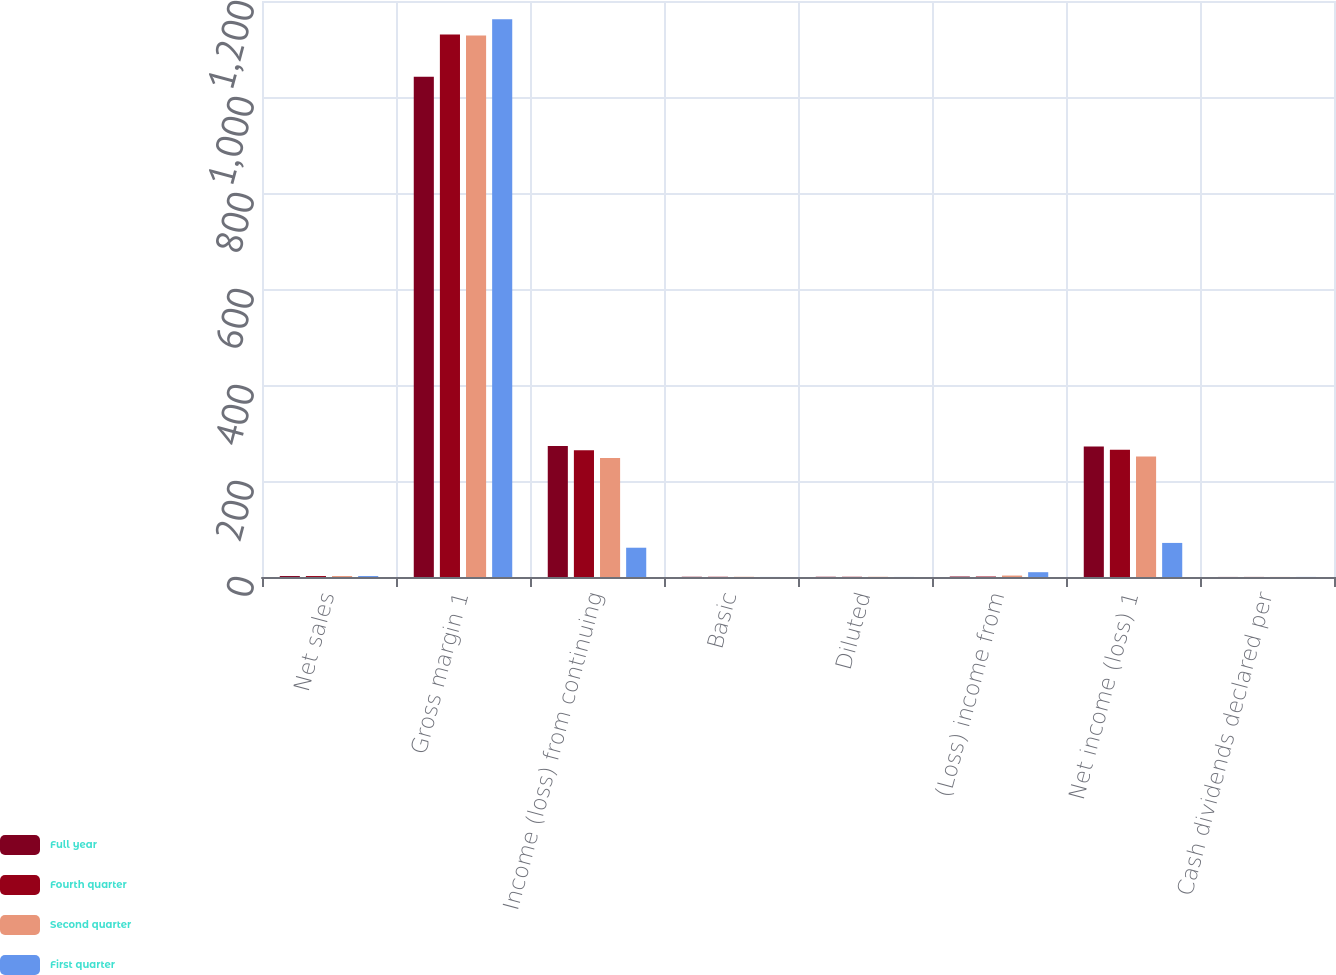Convert chart to OTSL. <chart><loc_0><loc_0><loc_500><loc_500><stacked_bar_chart><ecel><fcel>Net sales<fcel>Gross margin 1<fcel>Income (loss) from continuing<fcel>Basic<fcel>Diluted<fcel>(Loss) income from<fcel>Net income (loss) 1<fcel>Cash dividends declared per<nl><fcel>Full year<fcel>2<fcel>1042<fcel>273<fcel>0.5<fcel>0.5<fcel>1<fcel>272<fcel>0.13<nl><fcel>Fourth quarter<fcel>2<fcel>1130<fcel>264<fcel>0.49<fcel>0.48<fcel>1<fcel>265<fcel>0.16<nl><fcel>Second quarter<fcel>2<fcel>1128<fcel>248<fcel>0.46<fcel>0.45<fcel>3<fcel>251<fcel>0.16<nl><fcel>First quarter<fcel>2<fcel>1162<fcel>61<fcel>0.11<fcel>0.11<fcel>10<fcel>71<fcel>0.16<nl></chart> 